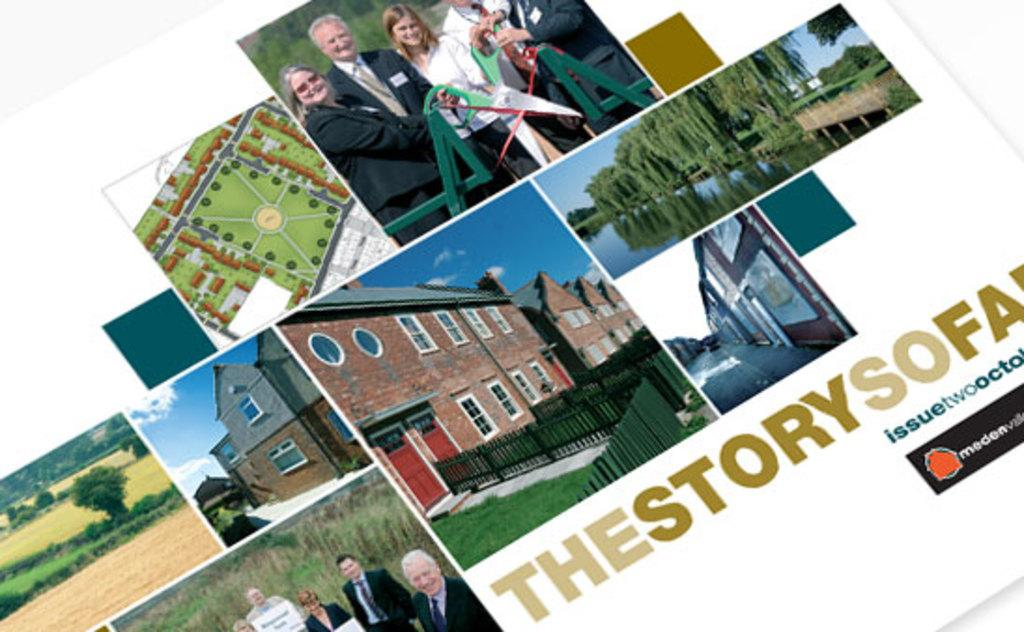What type of artwork is depicted in the image? The image is a collage of images. What subjects are included in the collage? There are images of trees, people, and an aerial view of fields in the collage. Is there any text present in the image? Yes, there is text written on the collage. What type of grain is being used as bait in the image? There is no grain or bait present in the image; it is a collage of images featuring trees, people, and fields. How much does the quarter-sized object cost in the image? There is no quarter-sized object present in the image. 